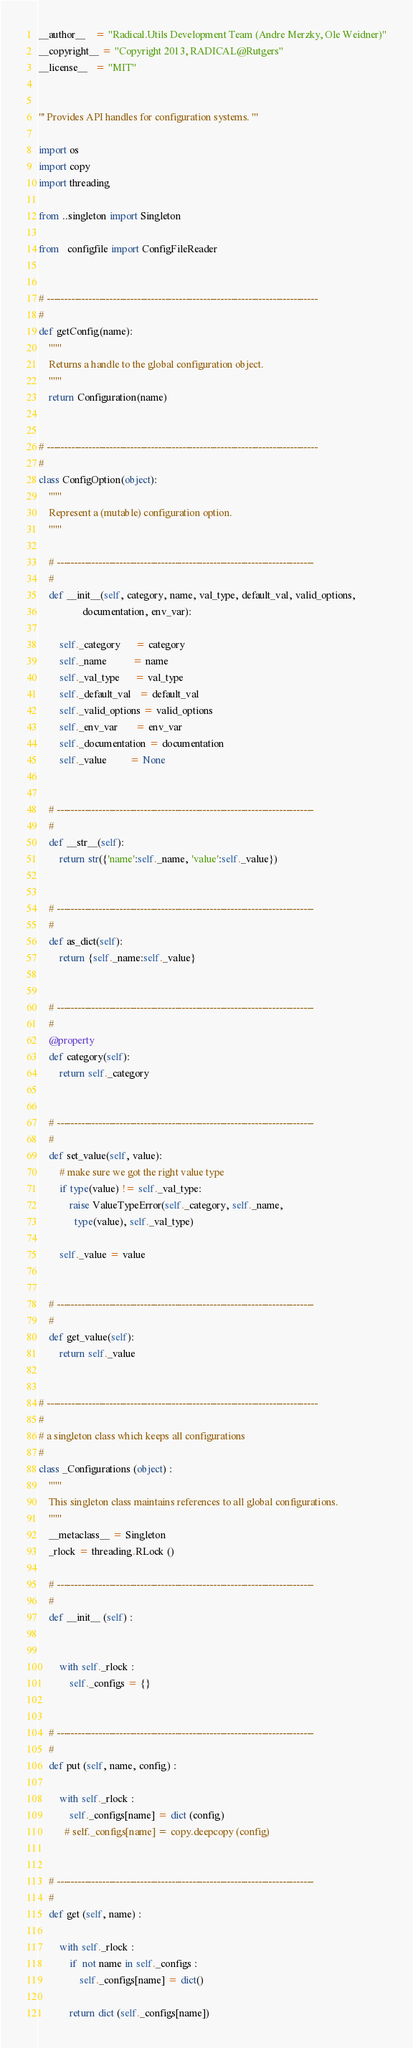Convert code to text. <code><loc_0><loc_0><loc_500><loc_500><_Python_>
__author__    = "Radical.Utils Development Team (Andre Merzky, Ole Weidner)"
__copyright__ = "Copyright 2013, RADICAL@Rutgers"
__license__   = "MIT"


''' Provides API handles for configuration systems. '''

import os
import copy
import threading

from ..singleton import Singleton

from   configfile import ConfigFileReader


# ------------------------------------------------------------------------------
#
def getConfig(name):
    """ 
    Returns a handle to the global configuration object.
    """
    return Configuration(name) 


# ------------------------------------------------------------------------------
#
class ConfigOption(object):
    """ 
    Represent a (mutable) configuration option.
    """

    # --------------------------------------------------------------------------
    #
    def __init__(self, category, name, val_type, default_val, valid_options,
                 documentation, env_var):

        self._category      = category
        self._name          = name
        self._val_type      = val_type
        self._default_val   = default_val
        self._valid_options = valid_options
        self._env_var       = env_var
        self._documentation = documentation
        self._value         = None


    # --------------------------------------------------------------------------
    #
    def __str__(self):
        return str({'name':self._name, 'value':self._value})


    # --------------------------------------------------------------------------
    #
    def as_dict(self):
        return {self._name:self._value}


    # --------------------------------------------------------------------------
    #
    @property
    def category(self):
        return self._category


    # --------------------------------------------------------------------------
    #
    def set_value(self, value):
        # make sure we got the right value type
        if type(value) != self._val_type:
            raise ValueTypeError(self._category, self._name, 
              type(value), self._val_type)

        self._value = value


    # --------------------------------------------------------------------------
    #
    def get_value(self):
        return self._value


# ------------------------------------------------------------------------------
#
# a singleton class which keeps all configurations
#
class _Configurations (object) :
    """
    This singleton class maintains references to all global configurations.
    """
    __metaclass__ = Singleton
    _rlock = threading.RLock ()

    # --------------------------------------------------------------------------
    #
    def __init__ (self) :


        with self._rlock :
            self._configs = {}


    # --------------------------------------------------------------------------
    #
    def put (self, name, config) :

        with self._rlock :
            self._configs[name] = dict (config)
          # self._configs[name] = copy.deepcopy (config)


    # --------------------------------------------------------------------------
    #
    def get (self, name) :

        with self._rlock :
            if  not name in self._configs :
                self._configs[name] = dict()

            return dict (self._configs[name])</code> 